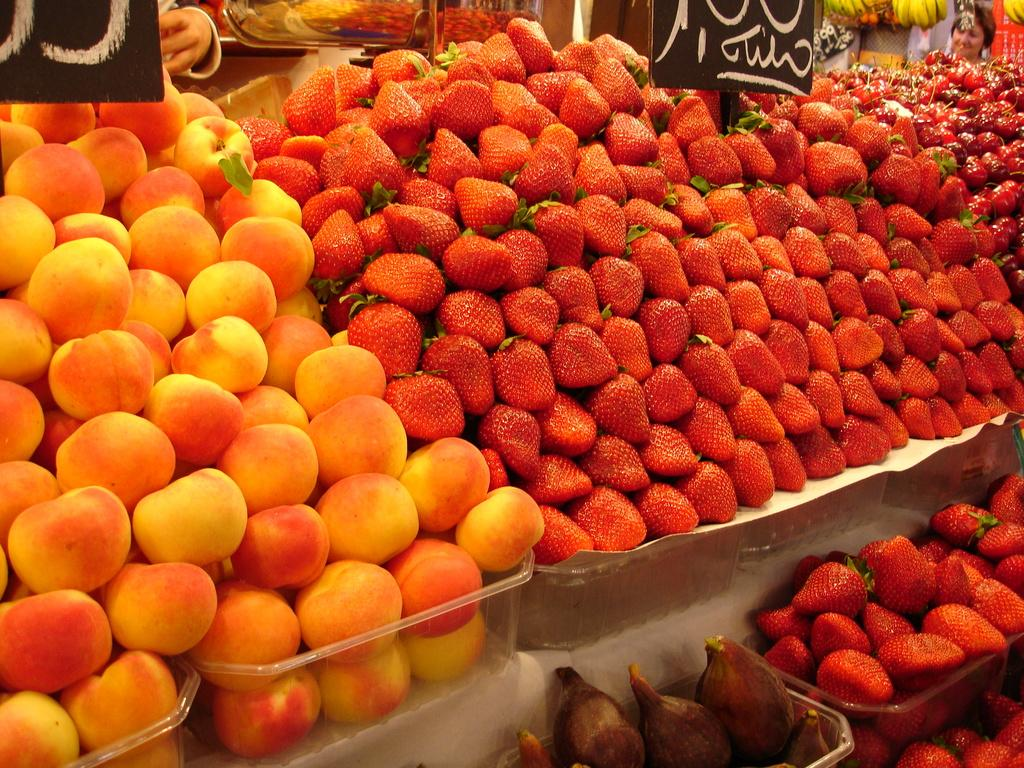What type of fruit can be seen in the image? There are strawberries in the image. Are there any other types of fruit besides strawberries? Yes, there are other fruits in the image. How are the fruits stored or displayed in the image? The fruits are kept in containers. Can you describe the presence of a person in the image? There is a person's head in the top right corner of the image. What type of reward can be seen in the image? There is no reward present in the image; it features fruits in containers and a person's head in the top right corner. Can you describe the play area for the birds in the image? There is no play area or birds present in the image. 